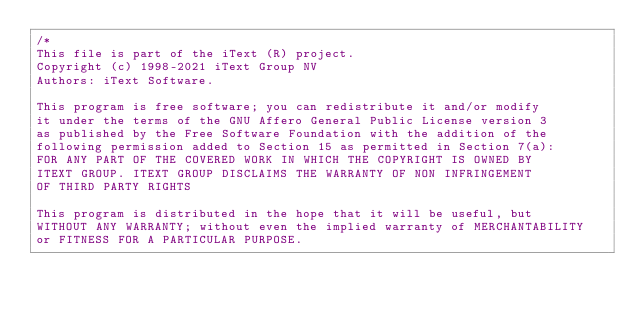<code> <loc_0><loc_0><loc_500><loc_500><_C#_>/*
This file is part of the iText (R) project.
Copyright (c) 1998-2021 iText Group NV
Authors: iText Software.

This program is free software; you can redistribute it and/or modify
it under the terms of the GNU Affero General Public License version 3
as published by the Free Software Foundation with the addition of the
following permission added to Section 15 as permitted in Section 7(a):
FOR ANY PART OF THE COVERED WORK IN WHICH THE COPYRIGHT IS OWNED BY
ITEXT GROUP. ITEXT GROUP DISCLAIMS THE WARRANTY OF NON INFRINGEMENT
OF THIRD PARTY RIGHTS

This program is distributed in the hope that it will be useful, but
WITHOUT ANY WARRANTY; without even the implied warranty of MERCHANTABILITY
or FITNESS FOR A PARTICULAR PURPOSE.</code> 